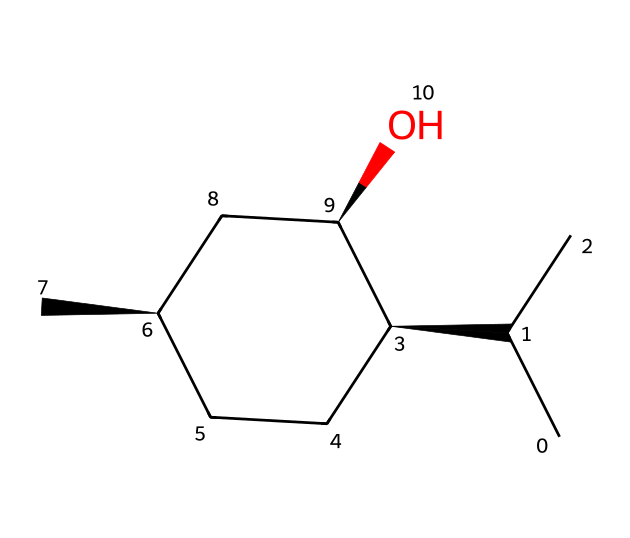What is the systematic name of this compound? The systematic name of a compound is often derived from the structure based on IUPAC nomenclature. In this case, the SMILES represents menthol, which is derived from mentha, the plant genus for mint.
Answer: menthol How many stereocenters are present in this compound? Identifying stereocenters involves finding the carbon atoms that have four different groups attached. In the given structure, there are three such carbon atoms, confirming that there are three stereocenters.
Answer: 3 What is the degree of unsaturation in this compound? Degree of unsaturation can be calculated from the molecular formula or by visual inspection of rings and multiple bonds. This compound has a cyclic structure and contains all single bonds. By examination, it shows no double or triple bonds either. Therefore, the degree of unsaturation is 1 due to the ring structure.
Answer: 1 How many carbon atoms are present in this compound? By analyzing the SMILES representation, we can count all carbon atoms indicated directly. There are ten carbon atoms in this structure.
Answer: 10 What type of chiral compound is menthol? Chiral compounds can be classified based on their structure and optical activity. Menthol is classified as a tertiary alcohol due to the presence of the hydroxyl (–OH) group on a carbon that is attached to three other carbon atoms.
Answer: tertiary alcohol Which stereocenter is responsible for the cooling sensation associated with menthol? The specific stereocenter contributing to the unique sensory properties is the one with the hydroxyl group attached, which can be identified through its orientation in the 3D space of the molecule. In menthol, the specific configuration of one of its stereocenters is particularly responsible for its cooling effect, which can be linked to its natural form.
Answer: the (1R,2S) configuration 